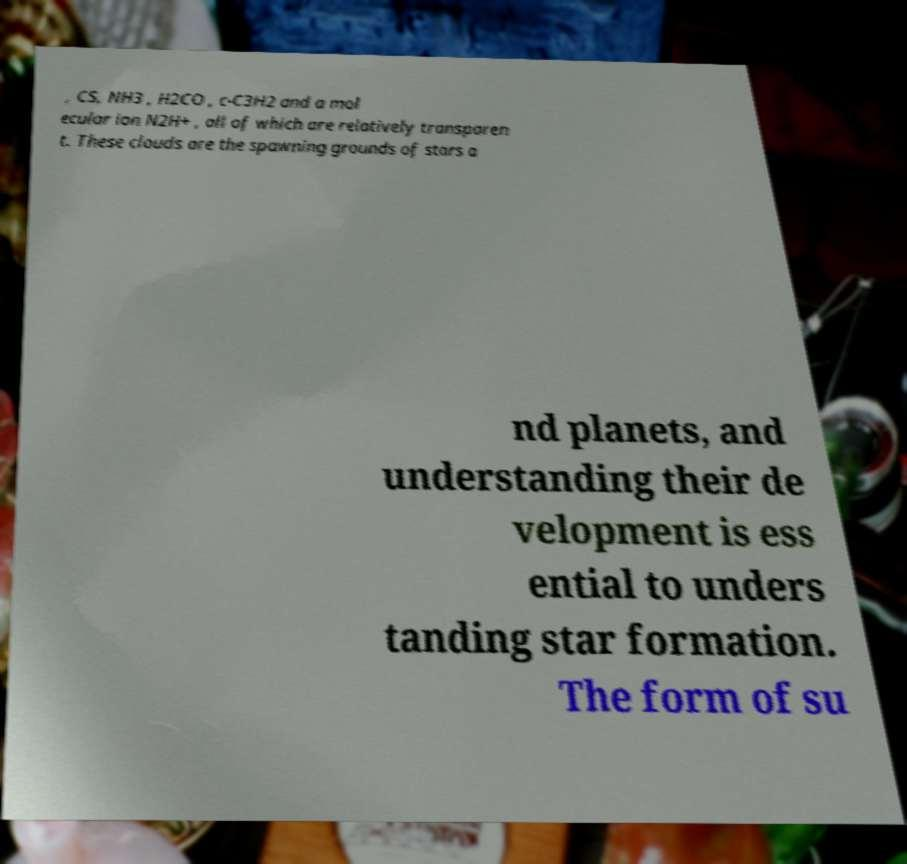Please identify and transcribe the text found in this image. , CS, NH3 , H2CO , c-C3H2 and a mol ecular ion N2H+ , all of which are relatively transparen t. These clouds are the spawning grounds of stars a nd planets, and understanding their de velopment is ess ential to unders tanding star formation. The form of su 